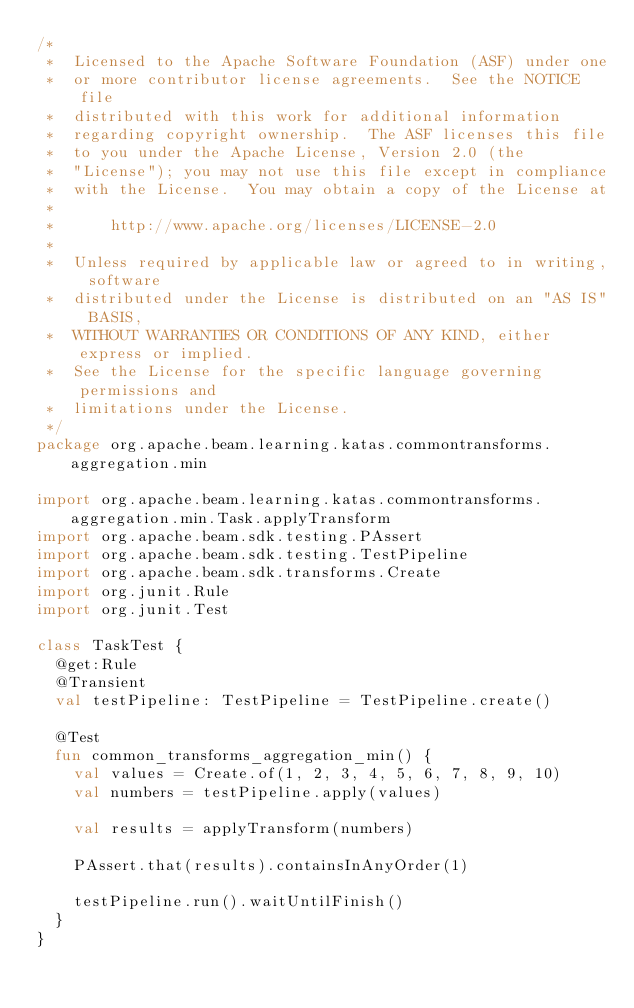Convert code to text. <code><loc_0><loc_0><loc_500><loc_500><_Kotlin_>/*
 *  Licensed to the Apache Software Foundation (ASF) under one
 *  or more contributor license agreements.  See the NOTICE file
 *  distributed with this work for additional information
 *  regarding copyright ownership.  The ASF licenses this file
 *  to you under the Apache License, Version 2.0 (the
 *  "License"); you may not use this file except in compliance
 *  with the License.  You may obtain a copy of the License at
 *
 *      http://www.apache.org/licenses/LICENSE-2.0
 *
 *  Unless required by applicable law or agreed to in writing, software
 *  distributed under the License is distributed on an "AS IS" BASIS,
 *  WITHOUT WARRANTIES OR CONDITIONS OF ANY KIND, either express or implied.
 *  See the License for the specific language governing permissions and
 *  limitations under the License.
 */
package org.apache.beam.learning.katas.commontransforms.aggregation.min

import org.apache.beam.learning.katas.commontransforms.aggregation.min.Task.applyTransform
import org.apache.beam.sdk.testing.PAssert
import org.apache.beam.sdk.testing.TestPipeline
import org.apache.beam.sdk.transforms.Create
import org.junit.Rule
import org.junit.Test

class TaskTest {
  @get:Rule
  @Transient
  val testPipeline: TestPipeline = TestPipeline.create()

  @Test
  fun common_transforms_aggregation_min() {
    val values = Create.of(1, 2, 3, 4, 5, 6, 7, 8, 9, 10)
    val numbers = testPipeline.apply(values)

    val results = applyTransform(numbers)

    PAssert.that(results).containsInAnyOrder(1)

    testPipeline.run().waitUntilFinish()
  }
}</code> 